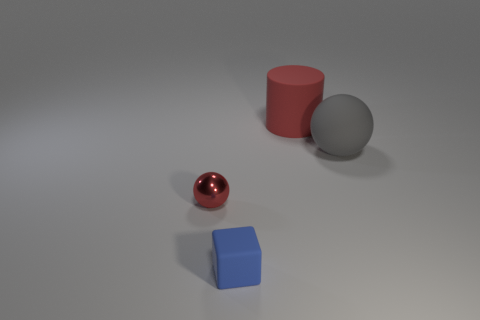Add 2 gray rubber balls. How many objects exist? 6 Subtract all red balls. How many balls are left? 1 Subtract 1 blocks. How many blocks are left? 0 Add 1 tiny red metallic spheres. How many tiny red metallic spheres are left? 2 Add 2 gray blocks. How many gray blocks exist? 2 Subtract 0 brown cylinders. How many objects are left? 4 Subtract all cylinders. How many objects are left? 3 Subtract all yellow balls. Subtract all brown cylinders. How many balls are left? 2 Subtract all purple blocks. How many red spheres are left? 1 Subtract all cubes. Subtract all small red metallic spheres. How many objects are left? 2 